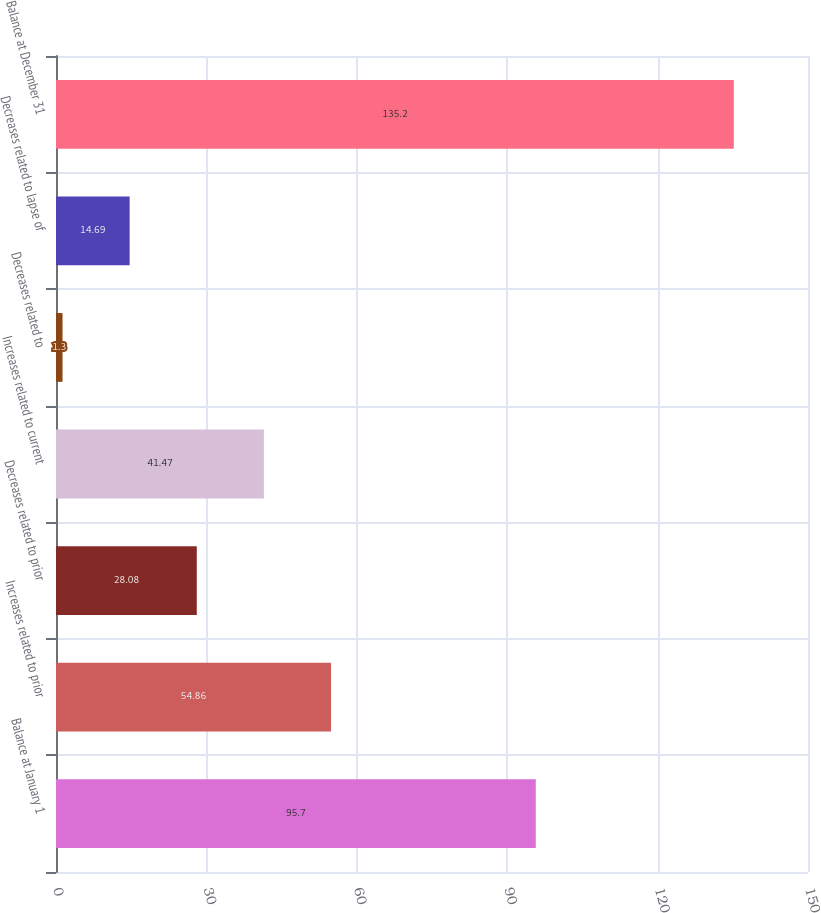<chart> <loc_0><loc_0><loc_500><loc_500><bar_chart><fcel>Balance at January 1<fcel>Increases related to prior<fcel>Decreases related to prior<fcel>Increases related to current<fcel>Decreases related to<fcel>Decreases related to lapse of<fcel>Balance at December 31<nl><fcel>95.7<fcel>54.86<fcel>28.08<fcel>41.47<fcel>1.3<fcel>14.69<fcel>135.2<nl></chart> 